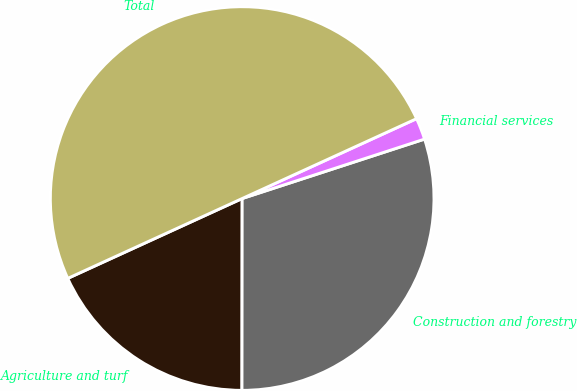Convert chart to OTSL. <chart><loc_0><loc_0><loc_500><loc_500><pie_chart><fcel>Agriculture and turf<fcel>Construction and forestry<fcel>Financial services<fcel>Total<nl><fcel>18.15%<fcel>30.03%<fcel>1.82%<fcel>50.0%<nl></chart> 